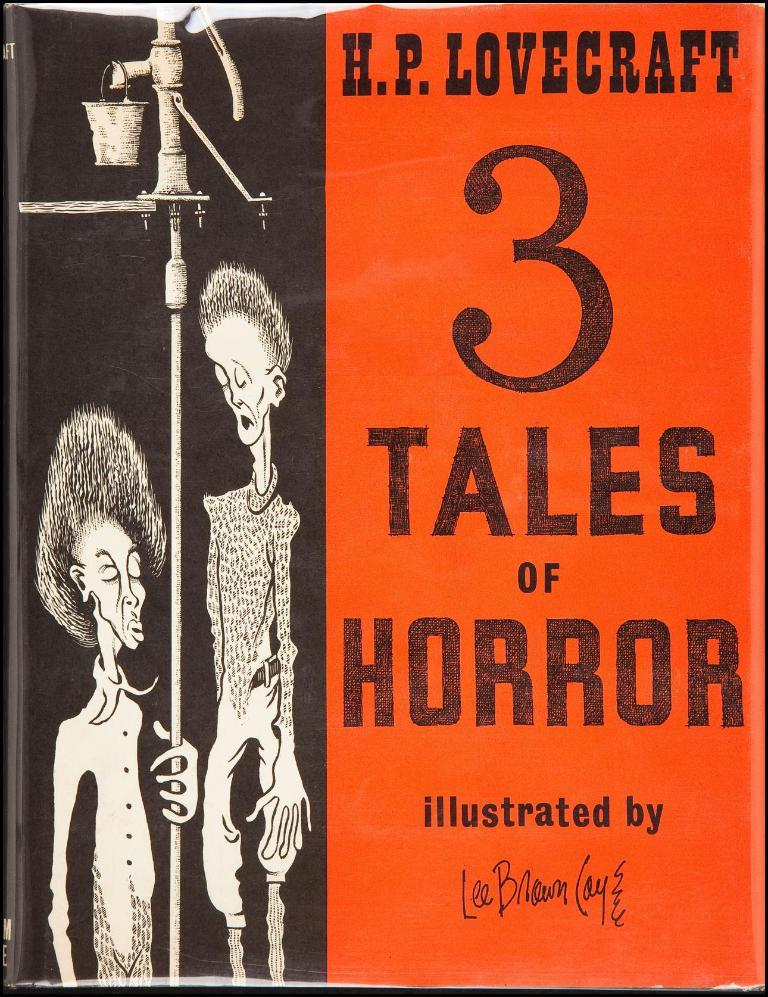What is featured in the image? There is a poster in the image. How many people are present in the image? There are two persons in the image. Where is the text located in relation to the image? The text is to the right of the image. What type of machine is visible in the image? There is no machine present in the image. What kind of border surrounds the image? The image does not show any borders. 